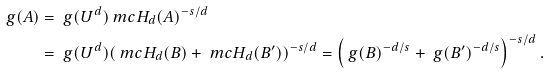Convert formula to latex. <formula><loc_0><loc_0><loc_500><loc_500>\ g ( A ) & = \ g ( U ^ { d } ) \ m c { H } _ { d } ( A ) ^ { - s / d } \\ & = \ g ( U ^ { d } ) ( \ m c { H } _ { d } ( B ) + \ m c { H } _ { d } ( B ^ { \prime } ) ) ^ { - s / d } = \left ( \ g ( B ) ^ { - d / s } + \ g ( B ^ { \prime } ) ^ { - d / s } \right ) ^ { - s / d } .</formula> 